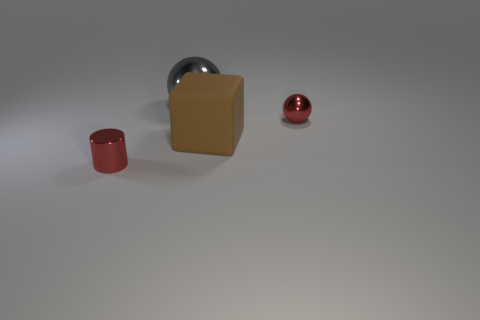Is there anything else that is made of the same material as the cylinder?
Offer a terse response. Yes. What size is the red thing that is left of the metal thing that is to the right of the large matte thing?
Provide a short and direct response. Small. Are there an equal number of tiny shiny spheres that are behind the tiny red ball and large brown rubber objects?
Keep it short and to the point. No. What number of other things are the same color as the small cylinder?
Ensure brevity in your answer.  1. Is the number of large objects on the right side of the large sphere less than the number of large red matte balls?
Your answer should be compact. No. Are there any yellow matte cylinders that have the same size as the red cylinder?
Offer a terse response. No. Is the color of the small metallic cylinder the same as the sphere that is to the right of the matte cube?
Keep it short and to the point. Yes. What number of small red shiny spheres are right of the tiny red metallic object in front of the big brown matte block?
Ensure brevity in your answer.  1. What color is the small metal object that is behind the tiny red metal thing that is in front of the small red shiny sphere?
Provide a short and direct response. Red. The thing that is both right of the big gray metallic thing and behind the large rubber block is made of what material?
Provide a succinct answer. Metal. 